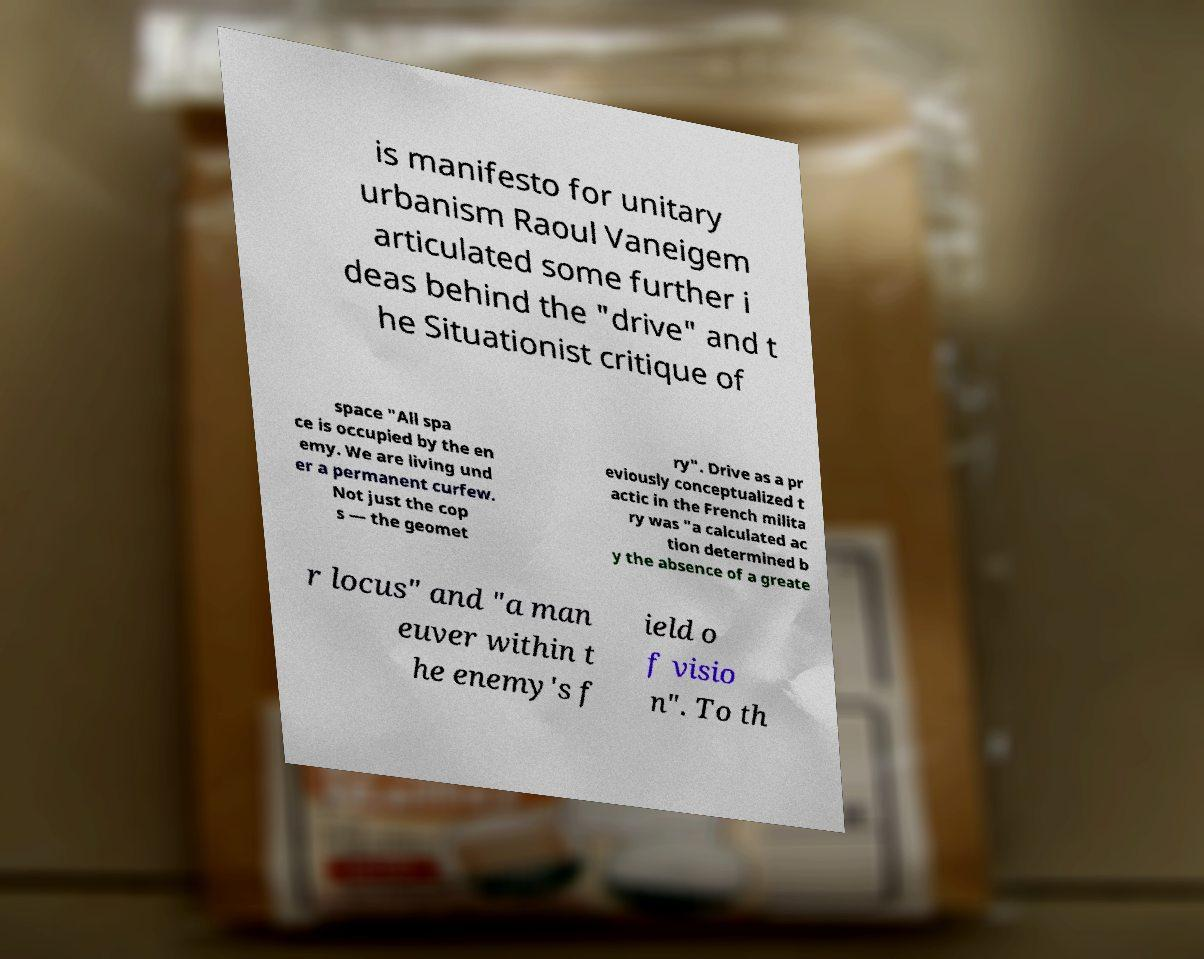Please read and relay the text visible in this image. What does it say? is manifesto for unitary urbanism Raoul Vaneigem articulated some further i deas behind the "drive" and t he Situationist critique of space "All spa ce is occupied by the en emy. We are living und er a permanent curfew. Not just the cop s — the geomet ry". Drive as a pr eviously conceptualized t actic in the French milita ry was "a calculated ac tion determined b y the absence of a greate r locus" and "a man euver within t he enemy's f ield o f visio n". To th 